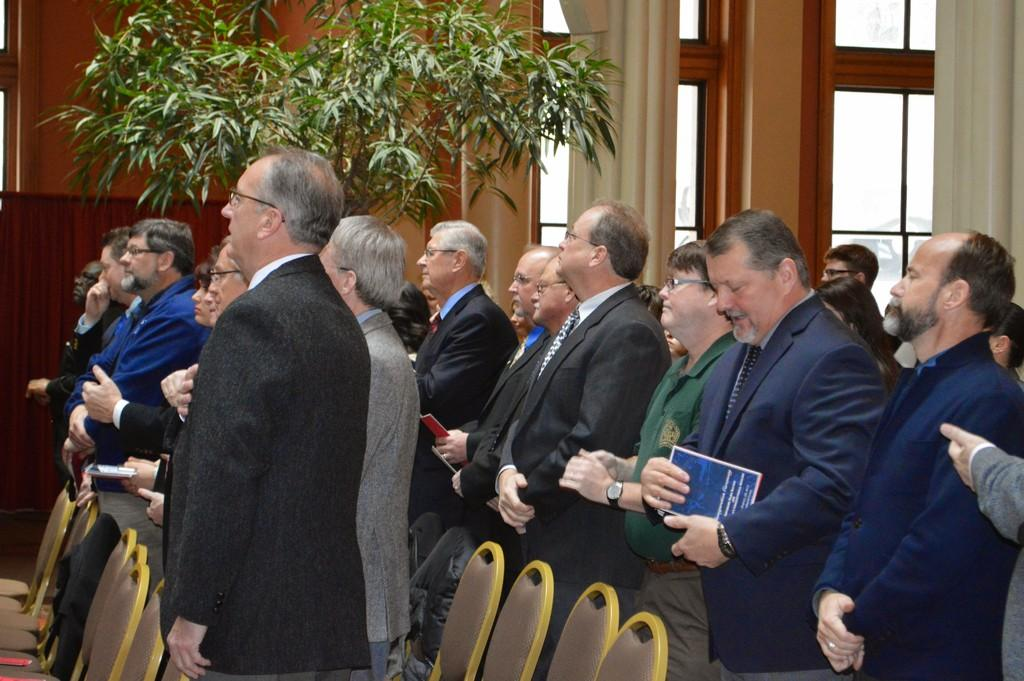What are the people in the image doing? The people in the image are standing. What are some of the people holding? Some people are holding objects. What type of furniture is present in the image? There are chairs in the image. What can be seen in the background of the image? There is a building and a tree in the background of the image. How many ladybugs are crawling on the tree in the background of the image? There are no ladybugs present in the image; only a tree can be seen in the background. 